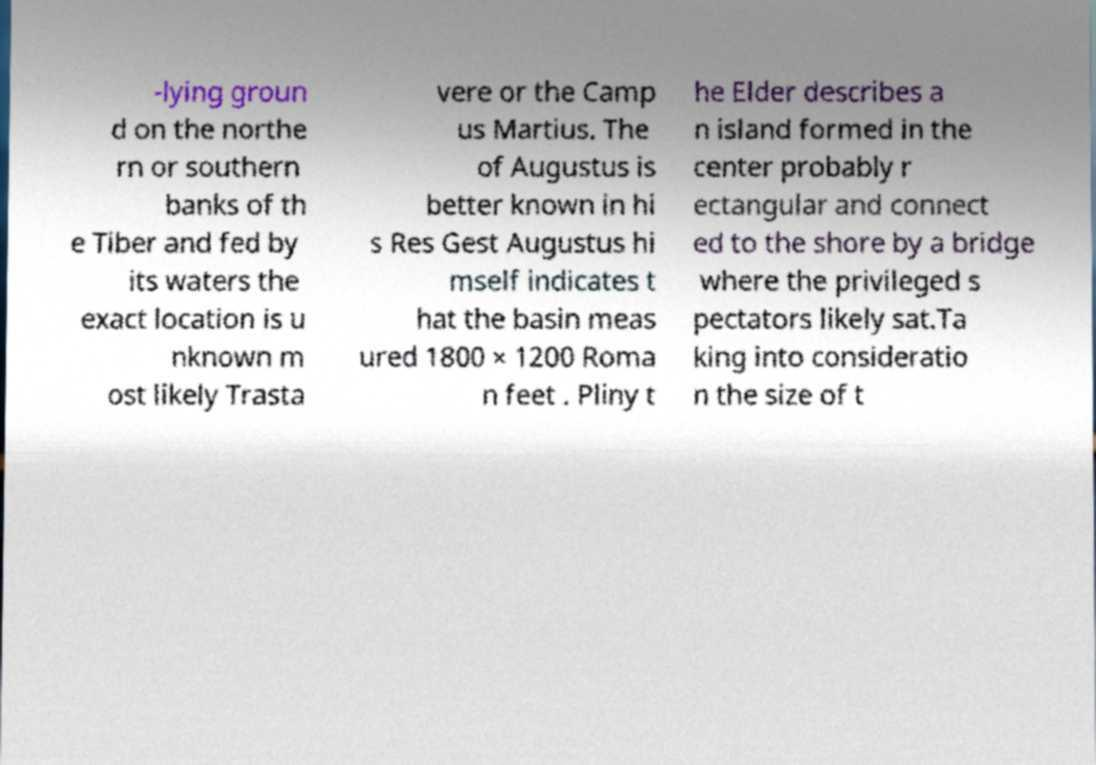There's text embedded in this image that I need extracted. Can you transcribe it verbatim? -lying groun d on the northe rn or southern banks of th e Tiber and fed by its waters the exact location is u nknown m ost likely Trasta vere or the Camp us Martius. The of Augustus is better known in hi s Res Gest Augustus hi mself indicates t hat the basin meas ured 1800 × 1200 Roma n feet . Pliny t he Elder describes a n island formed in the center probably r ectangular and connect ed to the shore by a bridge where the privileged s pectators likely sat.Ta king into consideratio n the size of t 